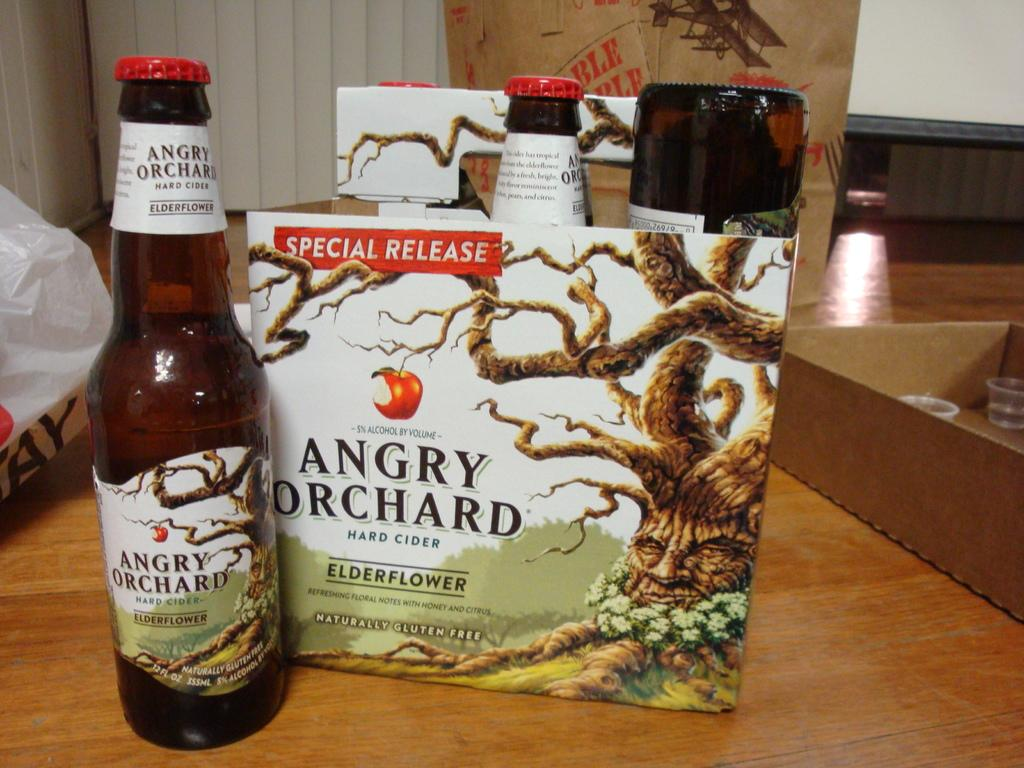<image>
Create a compact narrative representing the image presented. A closed bottle of angry orchard branded hard cider next to its container box. 